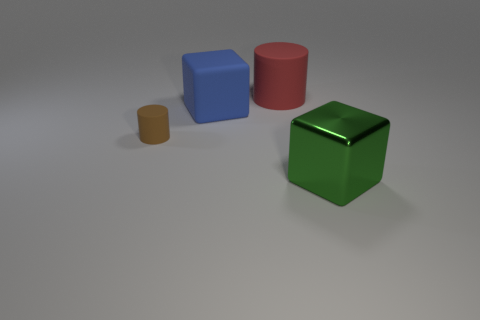Is the number of blocks that are to the right of the green block greater than the number of green blocks to the left of the blue cube?
Your response must be concise. No. How big is the blue thing?
Give a very brief answer. Large. There is a object on the right side of the big red rubber cylinder; does it have the same color as the large rubber cylinder?
Provide a succinct answer. No. Is there anything else that is the same shape as the red rubber thing?
Offer a very short reply. Yes. There is a cube that is on the right side of the red matte cylinder; are there any matte cubes that are right of it?
Offer a very short reply. No. Are there fewer large green metal cubes behind the large matte cube than rubber blocks that are right of the red thing?
Your response must be concise. No. How big is the block in front of the cube behind the object that is in front of the tiny brown thing?
Your response must be concise. Large. There is a cylinder that is in front of the rubber cube; is its size the same as the large red thing?
Make the answer very short. No. How many other things are there of the same material as the big green block?
Provide a succinct answer. 0. Are there more tiny objects than cyan rubber blocks?
Offer a terse response. Yes. 